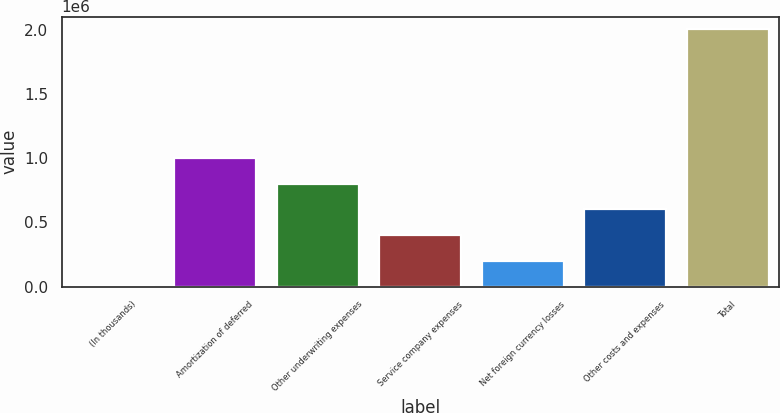Convert chart to OTSL. <chart><loc_0><loc_0><loc_500><loc_500><bar_chart><fcel>(In thousands)<fcel>Amortization of deferred<fcel>Other underwriting expenses<fcel>Service company expenses<fcel>Net foreign currency losses<fcel>Other costs and expenses<fcel>Total<nl><fcel>2013<fcel>1.00135e+06<fcel>801481<fcel>401747<fcel>201880<fcel>601614<fcel>2.00068e+06<nl></chart> 